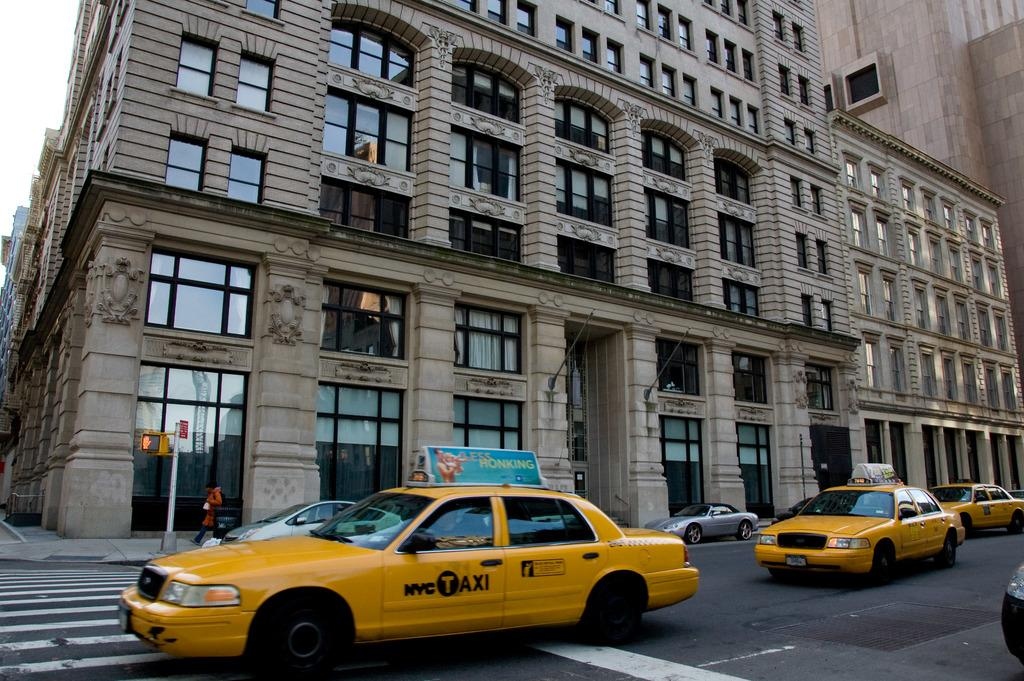<image>
Share a concise interpretation of the image provided. A NYC Taxi with a Less Honking sign on top of it, 